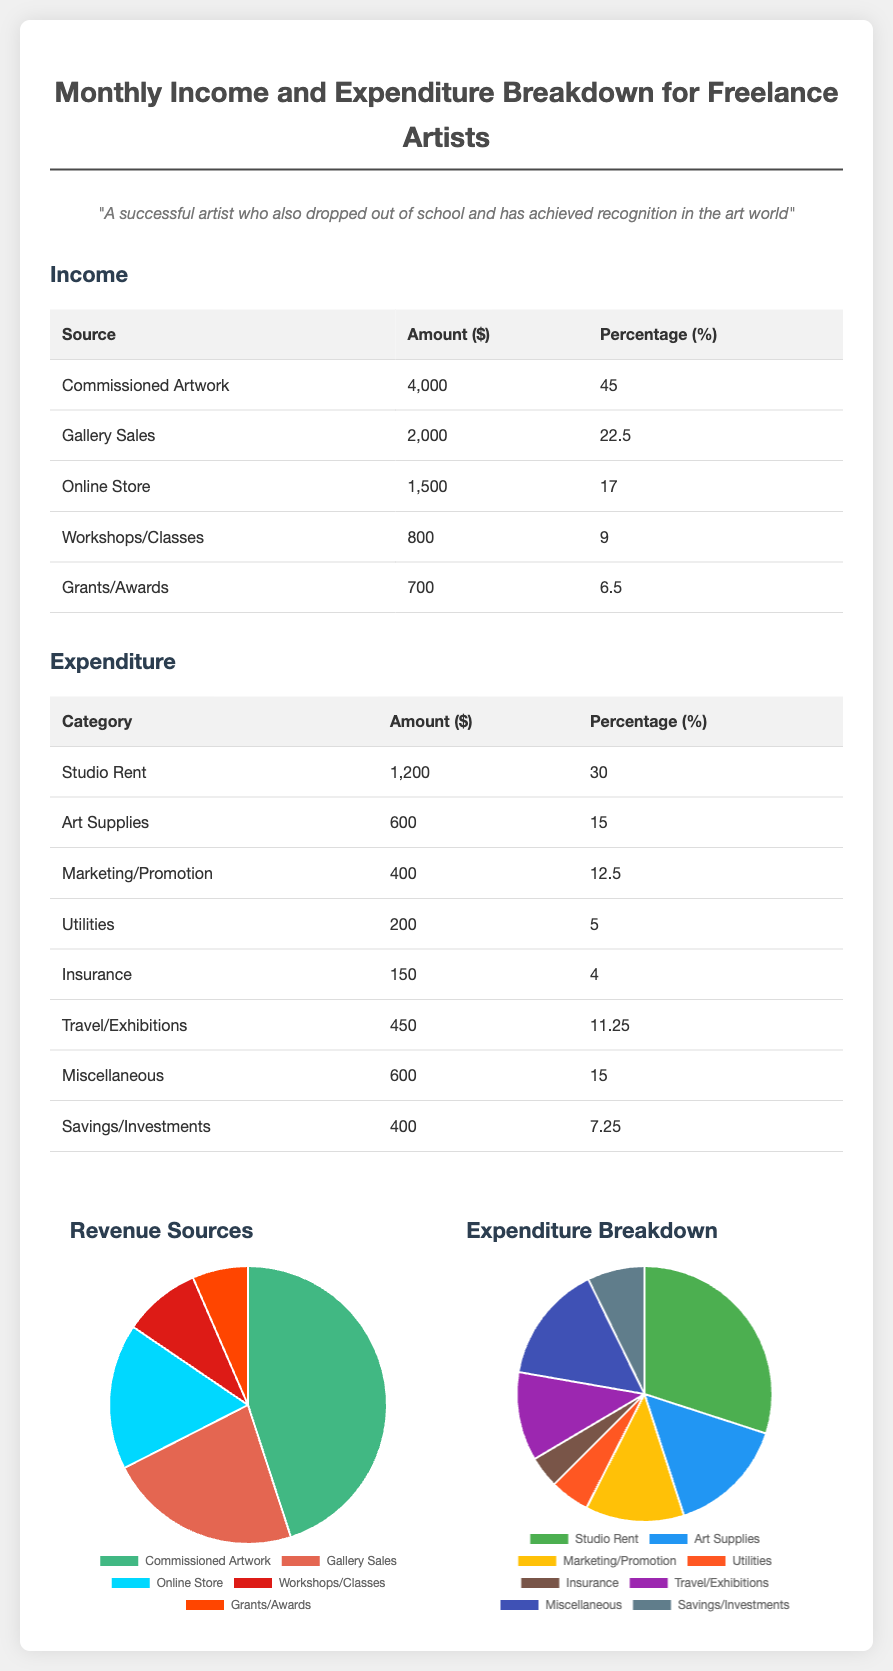What is the total income? The total income is the sum of all income sources, which includes $4000 + $2000 + $1500 + $800 + $700 = $9000.
Answer: $9000 What percentage of income comes from commissioned artwork? The document states that commissioned artwork accounts for 45% of the total income.
Answer: 45% What was the expenditure on studio rent? The document lists the studio rent as $1200.
Answer: $1200 Which income source has the least contribution? Grants/Awards contribute the least amount of $700, which is also the lowest percentage at 6.5%.
Answer: Grants/Awards What is the highest expenditure category? The highest expenditure category is Studio Rent, amounting to $1200.
Answer: Studio Rent What percentage of total expenditure is allocated to miscellaneous expenses? The document indicates that miscellaneous expenses account for 15% of total expenditure.
Answer: 15% What is the total percentage of income from online sales (store and commissions)? The total percentage from the online store (17%) and commissioned artwork (45%) equals 62%.
Answer: 62% How much is spent on marketing and promotion? The document states that the expenditure on marketing/promotion is $400.
Answer: $400 Which category has the lowest expenditure? The category with the lowest expenditure is Insurance, which amounts to $150.
Answer: Insurance 